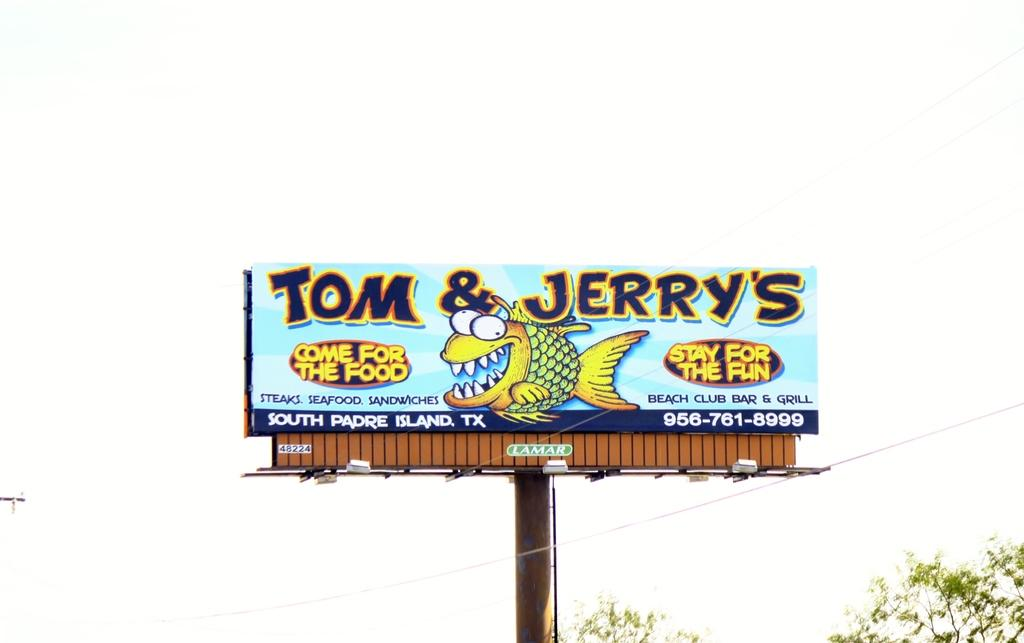<image>
Describe the image concisely. a billboard that says 'tom & jerry's' on the top of it 